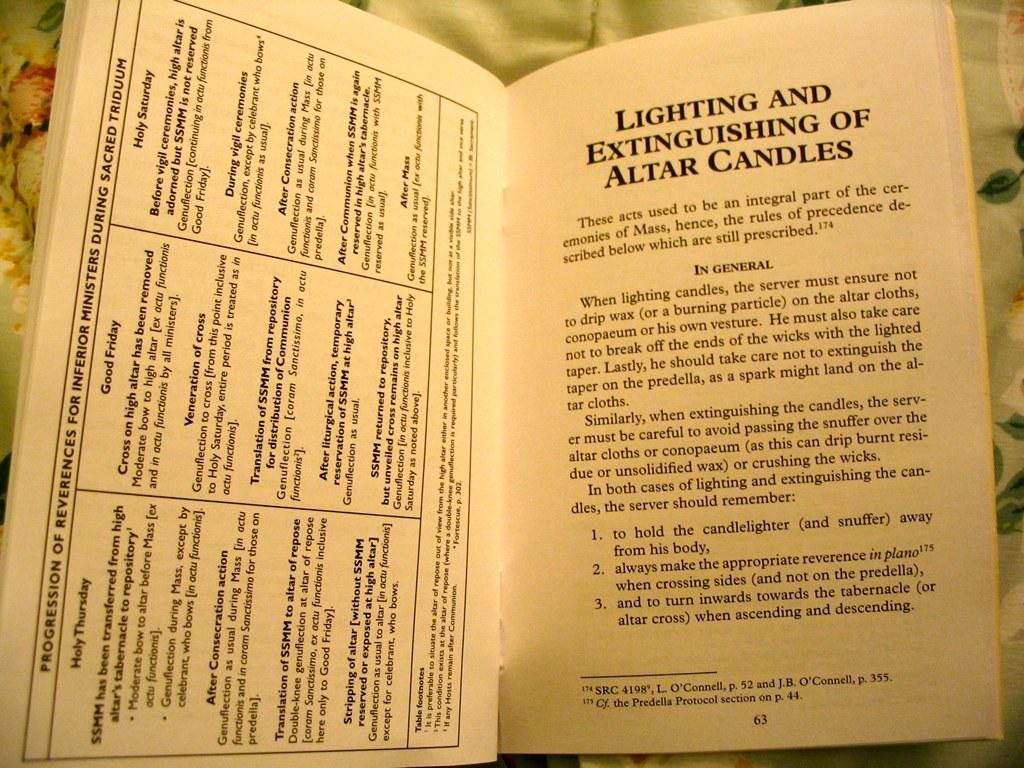<image>
Present a compact description of the photo's key features. A copy of a book called "Lighting and Extinguishing of Altar Candles" 